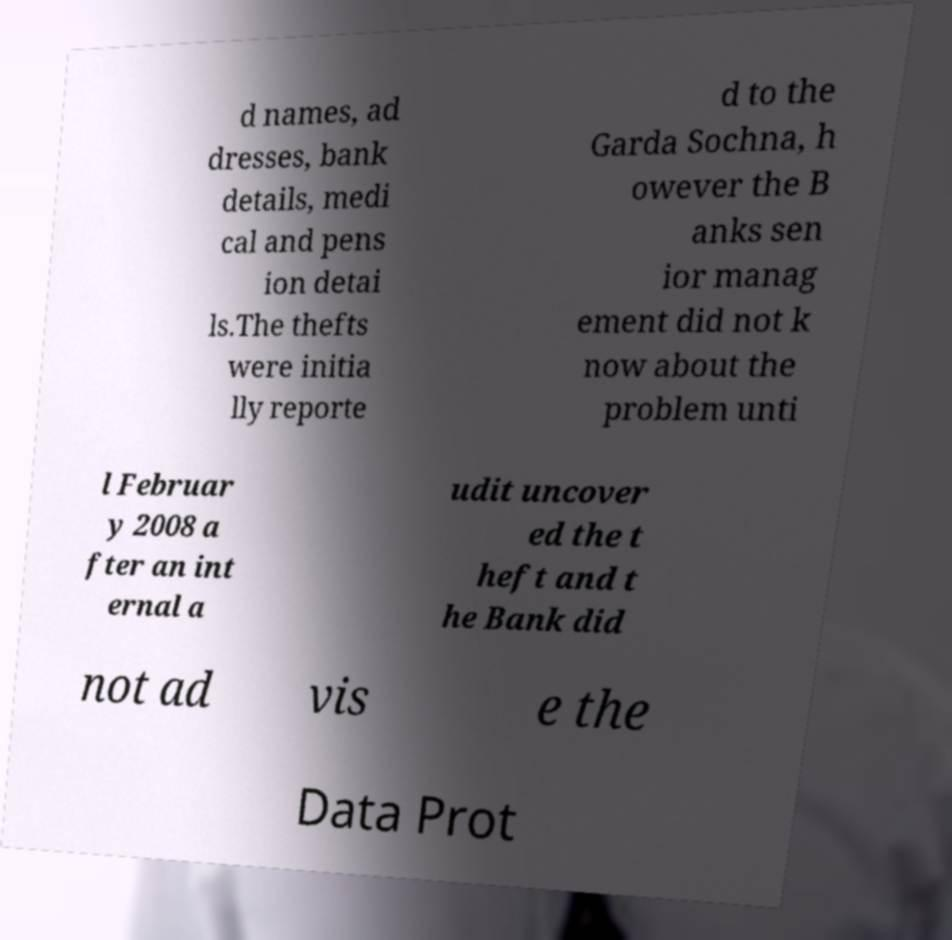Please identify and transcribe the text found in this image. d names, ad dresses, bank details, medi cal and pens ion detai ls.The thefts were initia lly reporte d to the Garda Sochna, h owever the B anks sen ior manag ement did not k now about the problem unti l Februar y 2008 a fter an int ernal a udit uncover ed the t heft and t he Bank did not ad vis e the Data Prot 